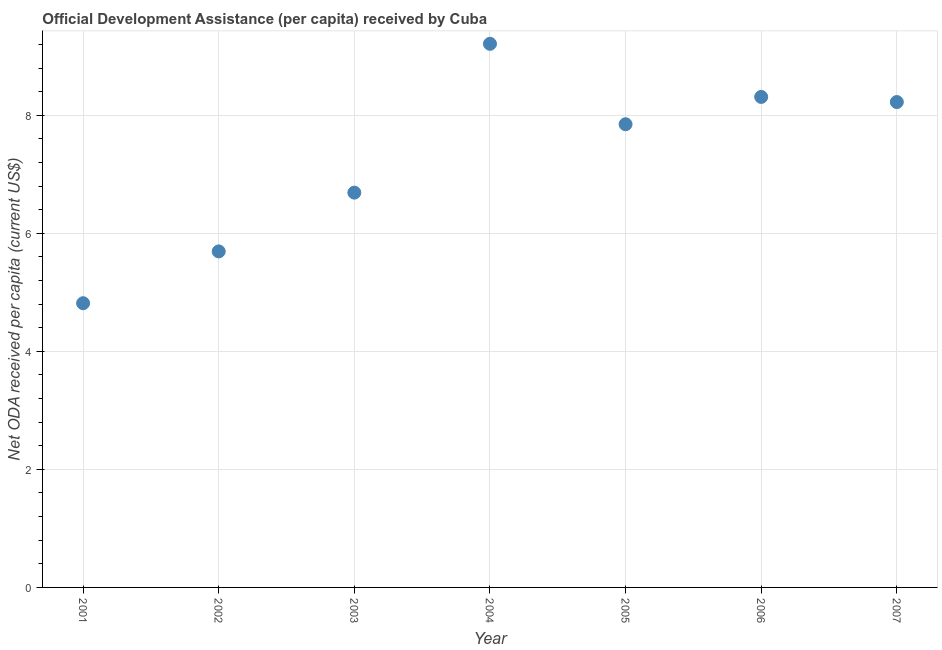What is the net oda received per capita in 2002?
Keep it short and to the point. 5.69. Across all years, what is the maximum net oda received per capita?
Keep it short and to the point. 9.21. Across all years, what is the minimum net oda received per capita?
Offer a very short reply. 4.82. In which year was the net oda received per capita maximum?
Your answer should be very brief. 2004. In which year was the net oda received per capita minimum?
Offer a very short reply. 2001. What is the sum of the net oda received per capita?
Your response must be concise. 50.79. What is the difference between the net oda received per capita in 2001 and 2006?
Your answer should be very brief. -3.5. What is the average net oda received per capita per year?
Your response must be concise. 7.26. What is the median net oda received per capita?
Make the answer very short. 7.85. In how many years, is the net oda received per capita greater than 7.2 US$?
Your answer should be compact. 4. Do a majority of the years between 2007 and 2006 (inclusive) have net oda received per capita greater than 2.4 US$?
Your response must be concise. No. What is the ratio of the net oda received per capita in 2003 to that in 2005?
Provide a short and direct response. 0.85. Is the net oda received per capita in 2003 less than that in 2007?
Provide a short and direct response. Yes. What is the difference between the highest and the second highest net oda received per capita?
Your answer should be compact. 0.9. What is the difference between the highest and the lowest net oda received per capita?
Ensure brevity in your answer.  4.4. In how many years, is the net oda received per capita greater than the average net oda received per capita taken over all years?
Offer a terse response. 4. Does the net oda received per capita monotonically increase over the years?
Your answer should be compact. No. How many dotlines are there?
Provide a succinct answer. 1. How many years are there in the graph?
Provide a succinct answer. 7. Are the values on the major ticks of Y-axis written in scientific E-notation?
Give a very brief answer. No. Does the graph contain grids?
Your response must be concise. Yes. What is the title of the graph?
Offer a very short reply. Official Development Assistance (per capita) received by Cuba. What is the label or title of the X-axis?
Give a very brief answer. Year. What is the label or title of the Y-axis?
Provide a short and direct response. Net ODA received per capita (current US$). What is the Net ODA received per capita (current US$) in 2001?
Keep it short and to the point. 4.82. What is the Net ODA received per capita (current US$) in 2002?
Keep it short and to the point. 5.69. What is the Net ODA received per capita (current US$) in 2003?
Your answer should be very brief. 6.69. What is the Net ODA received per capita (current US$) in 2004?
Make the answer very short. 9.21. What is the Net ODA received per capita (current US$) in 2005?
Your response must be concise. 7.85. What is the Net ODA received per capita (current US$) in 2006?
Ensure brevity in your answer.  8.31. What is the Net ODA received per capita (current US$) in 2007?
Give a very brief answer. 8.22. What is the difference between the Net ODA received per capita (current US$) in 2001 and 2002?
Provide a short and direct response. -0.88. What is the difference between the Net ODA received per capita (current US$) in 2001 and 2003?
Make the answer very short. -1.87. What is the difference between the Net ODA received per capita (current US$) in 2001 and 2004?
Offer a terse response. -4.4. What is the difference between the Net ODA received per capita (current US$) in 2001 and 2005?
Provide a succinct answer. -3.03. What is the difference between the Net ODA received per capita (current US$) in 2001 and 2006?
Offer a very short reply. -3.5. What is the difference between the Net ODA received per capita (current US$) in 2001 and 2007?
Your response must be concise. -3.41. What is the difference between the Net ODA received per capita (current US$) in 2002 and 2003?
Offer a very short reply. -1. What is the difference between the Net ODA received per capita (current US$) in 2002 and 2004?
Your answer should be compact. -3.52. What is the difference between the Net ODA received per capita (current US$) in 2002 and 2005?
Ensure brevity in your answer.  -2.15. What is the difference between the Net ODA received per capita (current US$) in 2002 and 2006?
Make the answer very short. -2.62. What is the difference between the Net ODA received per capita (current US$) in 2002 and 2007?
Make the answer very short. -2.53. What is the difference between the Net ODA received per capita (current US$) in 2003 and 2004?
Provide a succinct answer. -2.52. What is the difference between the Net ODA received per capita (current US$) in 2003 and 2005?
Your answer should be compact. -1.16. What is the difference between the Net ODA received per capita (current US$) in 2003 and 2006?
Give a very brief answer. -1.62. What is the difference between the Net ODA received per capita (current US$) in 2003 and 2007?
Keep it short and to the point. -1.53. What is the difference between the Net ODA received per capita (current US$) in 2004 and 2005?
Provide a succinct answer. 1.36. What is the difference between the Net ODA received per capita (current US$) in 2004 and 2006?
Offer a terse response. 0.9. What is the difference between the Net ODA received per capita (current US$) in 2004 and 2007?
Provide a succinct answer. 0.99. What is the difference between the Net ODA received per capita (current US$) in 2005 and 2006?
Keep it short and to the point. -0.46. What is the difference between the Net ODA received per capita (current US$) in 2005 and 2007?
Ensure brevity in your answer.  -0.38. What is the difference between the Net ODA received per capita (current US$) in 2006 and 2007?
Your response must be concise. 0.09. What is the ratio of the Net ODA received per capita (current US$) in 2001 to that in 2002?
Keep it short and to the point. 0.85. What is the ratio of the Net ODA received per capita (current US$) in 2001 to that in 2003?
Provide a short and direct response. 0.72. What is the ratio of the Net ODA received per capita (current US$) in 2001 to that in 2004?
Your response must be concise. 0.52. What is the ratio of the Net ODA received per capita (current US$) in 2001 to that in 2005?
Your answer should be compact. 0.61. What is the ratio of the Net ODA received per capita (current US$) in 2001 to that in 2006?
Your answer should be very brief. 0.58. What is the ratio of the Net ODA received per capita (current US$) in 2001 to that in 2007?
Your answer should be compact. 0.59. What is the ratio of the Net ODA received per capita (current US$) in 2002 to that in 2003?
Ensure brevity in your answer.  0.85. What is the ratio of the Net ODA received per capita (current US$) in 2002 to that in 2004?
Make the answer very short. 0.62. What is the ratio of the Net ODA received per capita (current US$) in 2002 to that in 2005?
Provide a succinct answer. 0.72. What is the ratio of the Net ODA received per capita (current US$) in 2002 to that in 2006?
Make the answer very short. 0.69. What is the ratio of the Net ODA received per capita (current US$) in 2002 to that in 2007?
Make the answer very short. 0.69. What is the ratio of the Net ODA received per capita (current US$) in 2003 to that in 2004?
Offer a very short reply. 0.73. What is the ratio of the Net ODA received per capita (current US$) in 2003 to that in 2005?
Your response must be concise. 0.85. What is the ratio of the Net ODA received per capita (current US$) in 2003 to that in 2006?
Keep it short and to the point. 0.81. What is the ratio of the Net ODA received per capita (current US$) in 2003 to that in 2007?
Offer a terse response. 0.81. What is the ratio of the Net ODA received per capita (current US$) in 2004 to that in 2005?
Your answer should be very brief. 1.17. What is the ratio of the Net ODA received per capita (current US$) in 2004 to that in 2006?
Ensure brevity in your answer.  1.11. What is the ratio of the Net ODA received per capita (current US$) in 2004 to that in 2007?
Keep it short and to the point. 1.12. What is the ratio of the Net ODA received per capita (current US$) in 2005 to that in 2006?
Offer a very short reply. 0.94. What is the ratio of the Net ODA received per capita (current US$) in 2005 to that in 2007?
Your answer should be very brief. 0.95. What is the ratio of the Net ODA received per capita (current US$) in 2006 to that in 2007?
Keep it short and to the point. 1.01. 